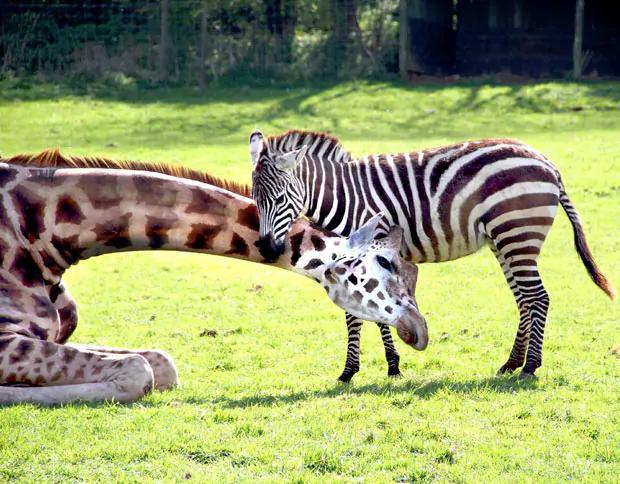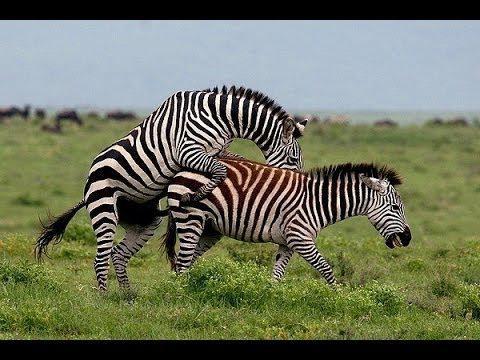The first image is the image on the left, the second image is the image on the right. Assess this claim about the two images: "The left image shows a smaller hooved animal next to a bigger hooved animal, and the right image shows one zebra with its front legs over another zebra's back.". Correct or not? Answer yes or no. Yes. The first image is the image on the left, the second image is the image on the right. Evaluate the accuracy of this statement regarding the images: "The left and right image contains the same number of adult zebras.". Is it true? Answer yes or no. No. 